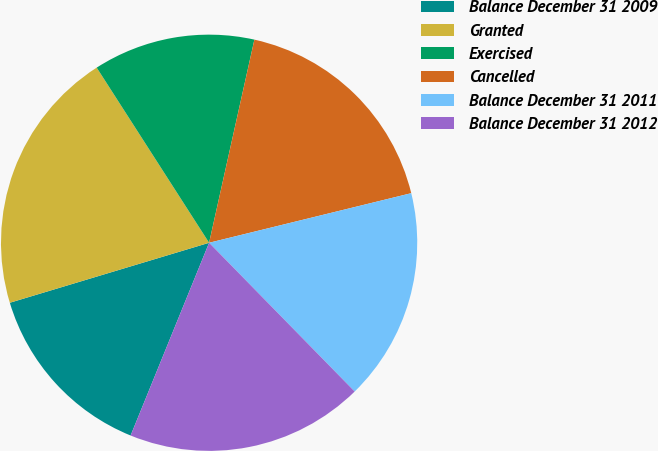Convert chart. <chart><loc_0><loc_0><loc_500><loc_500><pie_chart><fcel>Balance December 31 2009<fcel>Granted<fcel>Exercised<fcel>Cancelled<fcel>Balance December 31 2011<fcel>Balance December 31 2012<nl><fcel>14.19%<fcel>20.57%<fcel>12.57%<fcel>17.68%<fcel>16.5%<fcel>18.48%<nl></chart> 